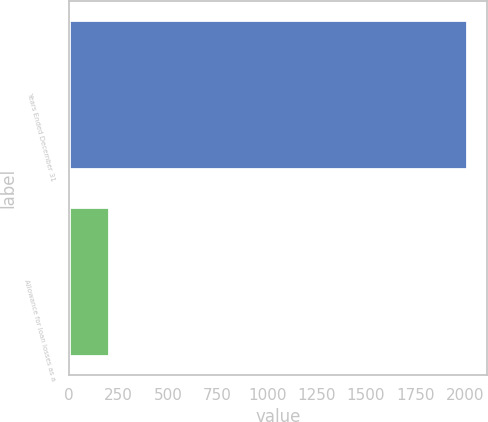<chart> <loc_0><loc_0><loc_500><loc_500><bar_chart><fcel>Years Ended December 31<fcel>Allowance for loan losses as a<nl><fcel>2012<fcel>202.43<nl></chart> 